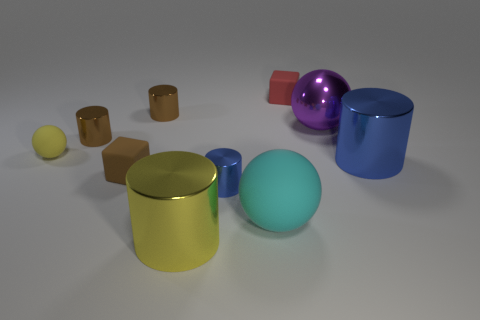How many brown cylinders must be subtracted to get 1 brown cylinders? 1 Subtract all blue metal cylinders. How many cylinders are left? 3 Subtract all yellow spheres. How many spheres are left? 2 Subtract 1 cubes. How many cubes are left? 1 Subtract all cubes. How many objects are left? 8 Subtract all red balls. How many brown cylinders are left? 2 Add 6 small blue metallic objects. How many small blue metallic objects exist? 7 Subtract 0 blue balls. How many objects are left? 10 Subtract all cyan cylinders. Subtract all blue cubes. How many cylinders are left? 5 Subtract all small red things. Subtract all yellow rubber balls. How many objects are left? 8 